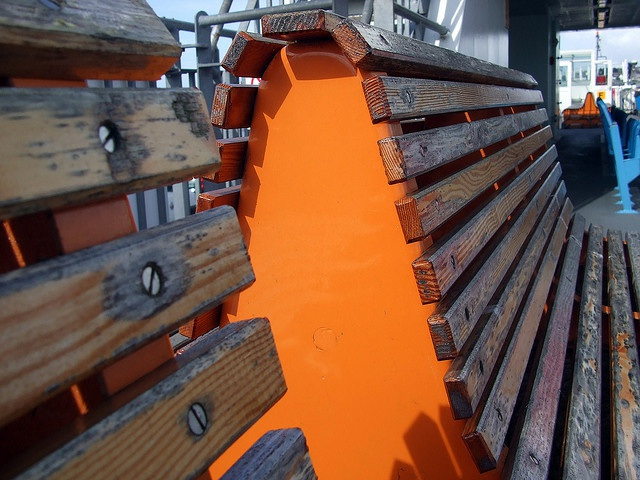Describe the objects in this image and their specific colors. I can see bench in gray, red, black, and orange tones and bench in gray, black, and maroon tones in this image. 